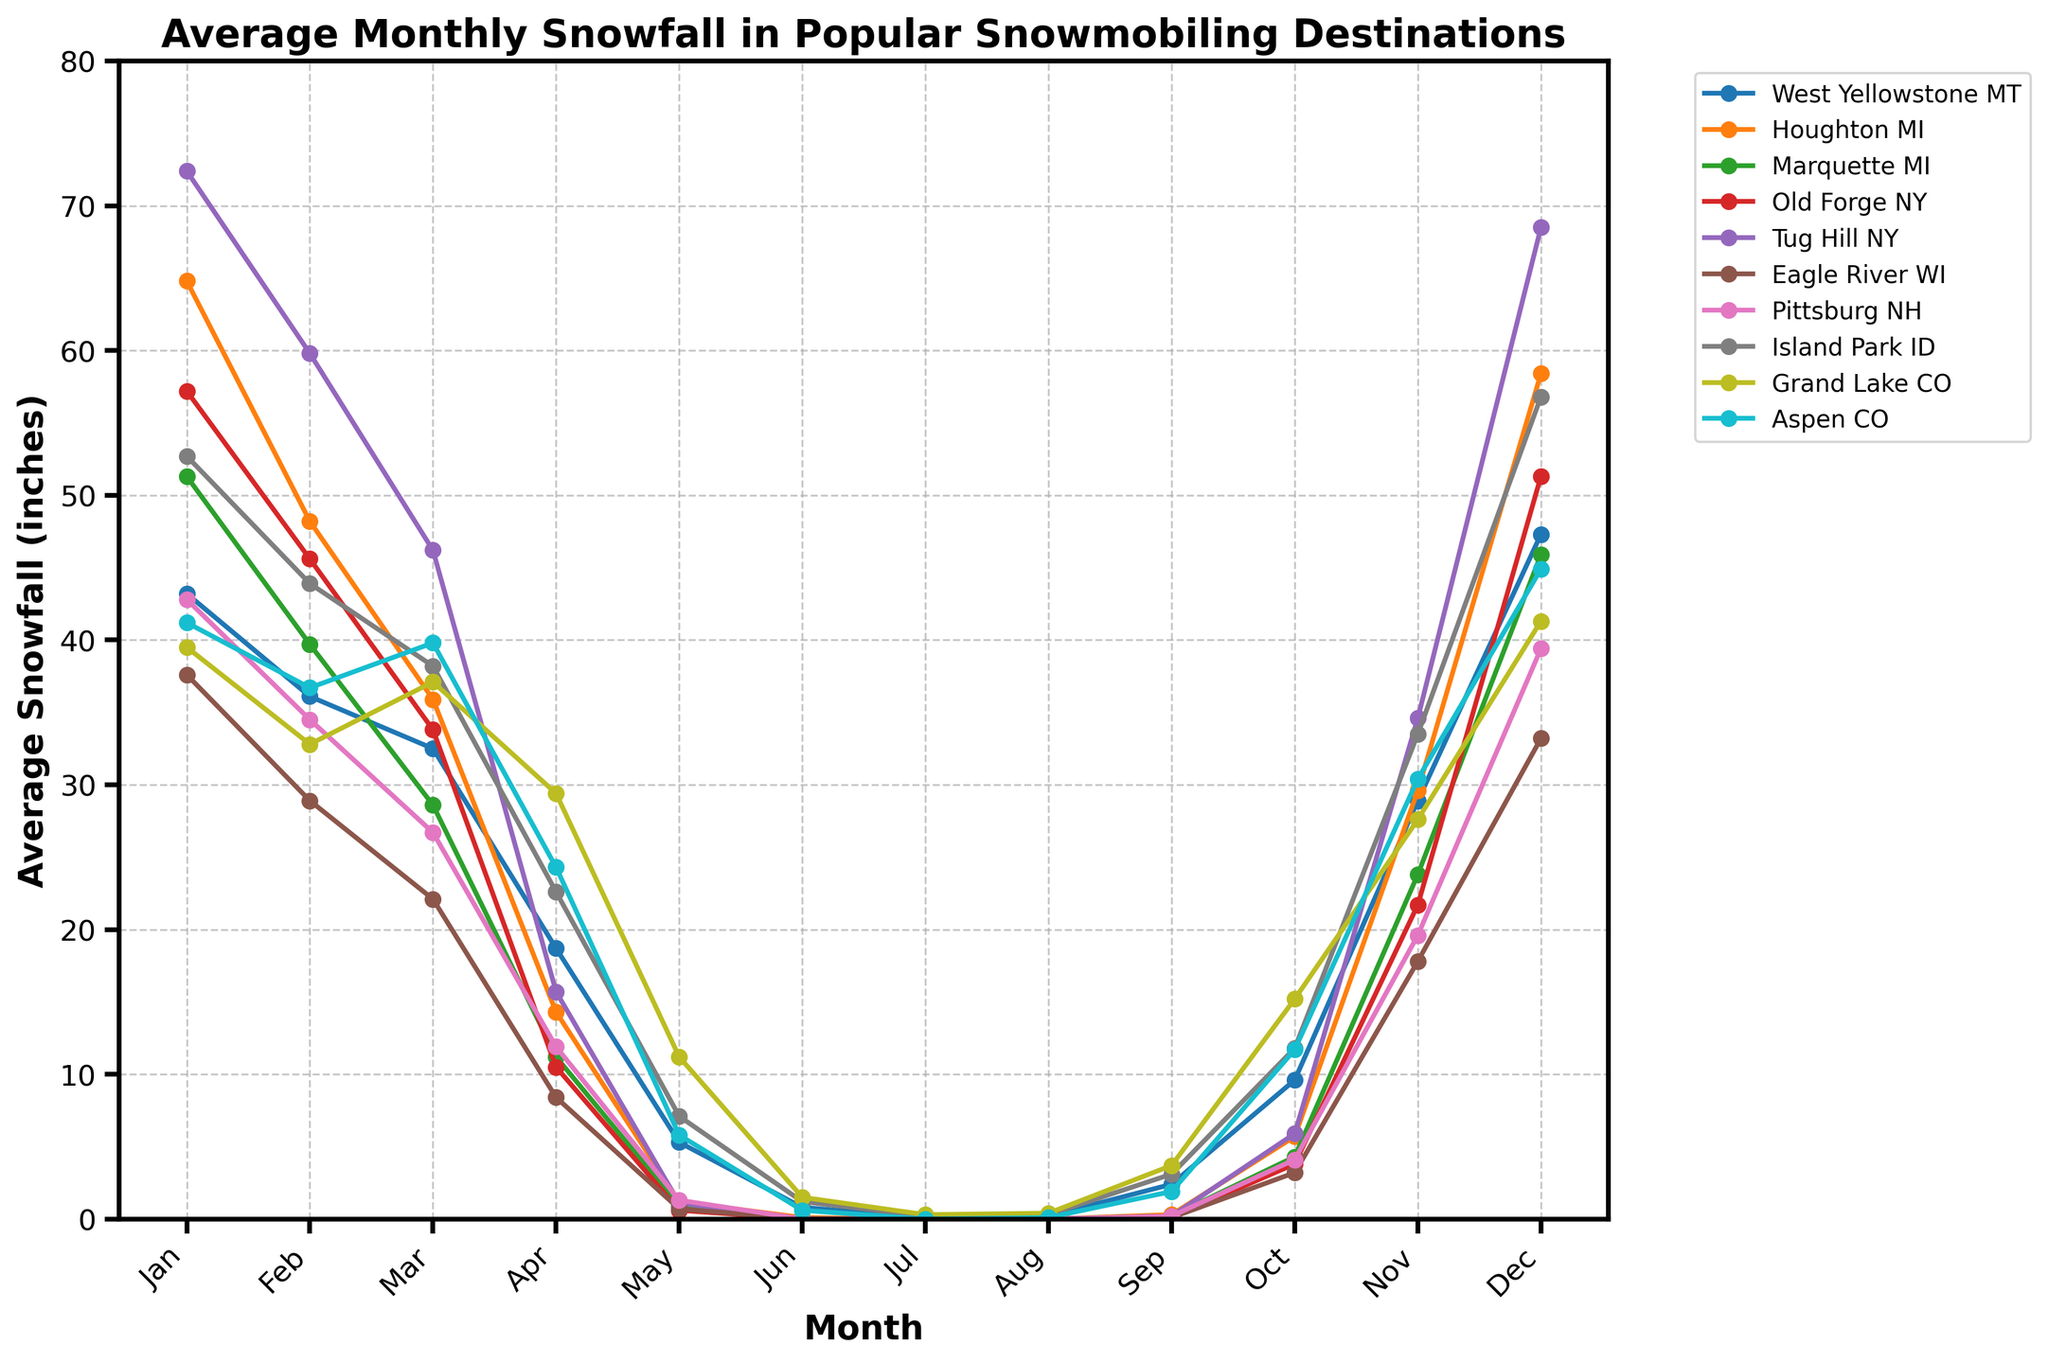Which location has the highest average snowfall in January? By observing the peaks of the lines for January, we can see that "Tug Hill NY" has the tallest peak.
Answer: Tug Hill NY Which month has the lowest average snowfall in Marquette MI? By following the line for Marquette MI and noting the lowest point, we can identify that June and July both show 0 average snowfall.
Answer: June, July In which month does West Yellowstone MT experience the highest average snowfall? We track the line representing West Yellowstone MT and see the highest point occurs in December.
Answer: December How does the average snowfall in December compare between Aspen CO and Pittsburg NH? We look for the points representing December for both Aspen CO and Pittsburg NH. Aspen CO has a slightly higher value at approximately 44.9 inches compared to Pittsburg NH at 39.4 inches.
Answer: Aspen CO has higher snowfall in December Which location shows the greatest fluctuation in average snowfall throughout the year, and in which months does it have its highest and lowest points? We examine the lines for large rises and falls. "Tug Hill NY" shows the greatest fluctuation, with the highest point in January (72.4 inches) and the lowest in July (0 inches).
Answer: Tug Hill NY (highest in January, lowest in July) What's the average of the highest average snowfall months across all locations? First find the highest snowfall month for each location, sum them up and divide by the number of locations. The highest points are: 43.2 (W.Y.), 64.8 (H.MI), 51.3 (M.MI), 57.2 (O.F.), 72.4 (T.H.), 37.6 (E.R.), 42.8 (P.NH), 56.8 (I.P.), 41.3 (G.L.), 44.9 (A.C.). So, (43.2 + 64.8 + 51.3 + 57.2 + 72.4 + 37.6 + 42.8 + 56.8 + 41.3 + 44.9)/10 = 51.23
Answer: 51.23 inches Which destination has the steepest decline in snowfall from January to February? By observing the slope of lines from January to February for each location, "Houghton MI" shows the steepest negative slope.
Answer: Houghton MI What is the total average snowfall in Grand Lake CO from January to December? Add up the snowfall values for each month in Grand Lake CO: 39.5 + 32.8 + 37.1 + 29.4 + 11.2 + 1.5 + 0.3 + 0.4 + 3.7 + 15.2 + 27.6 + 41.3 = 240
Answer: 240 inches What month has the smallest difference in snowfall between West Yellowstone MT and Marquette MI? Find differences for each month: 8 inches in May is the smallest (5.3-0.9), other differences are larger.
Answer: May Which destination has consistently low snowfall throughout the year and what is its highest monthly snowfall? "Eagle River WI" shows low snowfall values without large peaks. The highest is in January at 37.6 inches.
Answer: Eagle River WI, 37.6 inches 